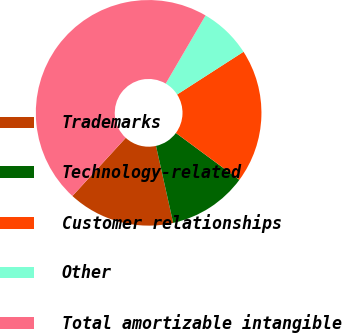Convert chart. <chart><loc_0><loc_0><loc_500><loc_500><pie_chart><fcel>Trademarks<fcel>Technology-related<fcel>Customer relationships<fcel>Other<fcel>Total amortizable intangible<nl><fcel>15.3%<fcel>11.39%<fcel>19.22%<fcel>7.48%<fcel>46.61%<nl></chart> 